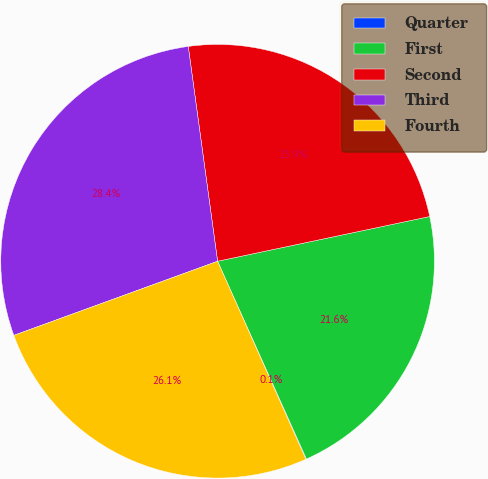Convert chart. <chart><loc_0><loc_0><loc_500><loc_500><pie_chart><fcel>Quarter<fcel>First<fcel>Second<fcel>Third<fcel>Fourth<nl><fcel>0.05%<fcel>21.58%<fcel>23.85%<fcel>28.39%<fcel>26.12%<nl></chart> 